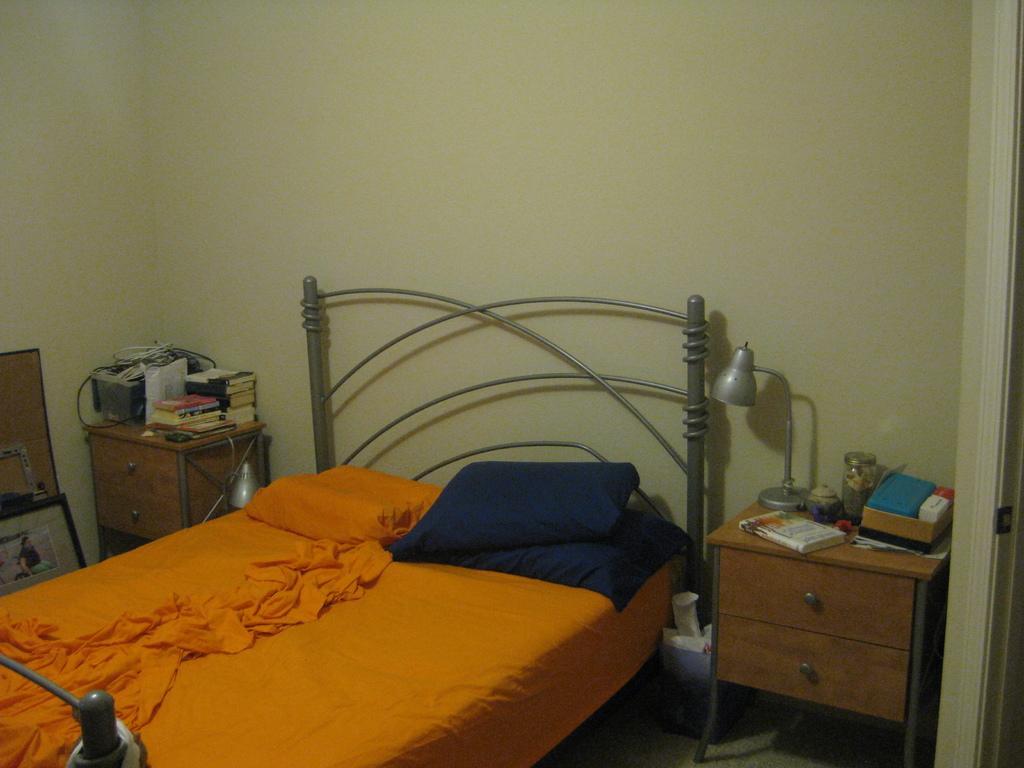Could you give a brief overview of what you see in this image? This picture is taken inside the room, In the middle there is a bed on the bed there is a orange color cloth, In the right side there is a table in yellow color, There are some books on the table, In the left side of the image, There is a yellow color table on that there are some books on the table, In the background there is a yellow color wall. 